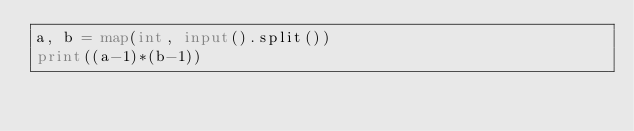<code> <loc_0><loc_0><loc_500><loc_500><_Python_>a, b = map(int, input().split())
print((a-1)*(b-1))
</code> 